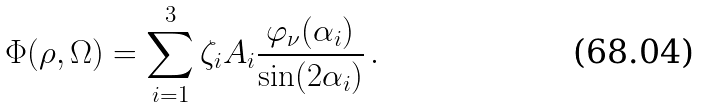<formula> <loc_0><loc_0><loc_500><loc_500>\Phi ( \rho , \Omega ) = \sum _ { i = 1 } ^ { 3 } \zeta _ { i } A _ { i } \frac { \varphi _ { \nu } ( \alpha _ { i } ) } { \sin ( 2 \alpha _ { i } ) } \, .</formula> 